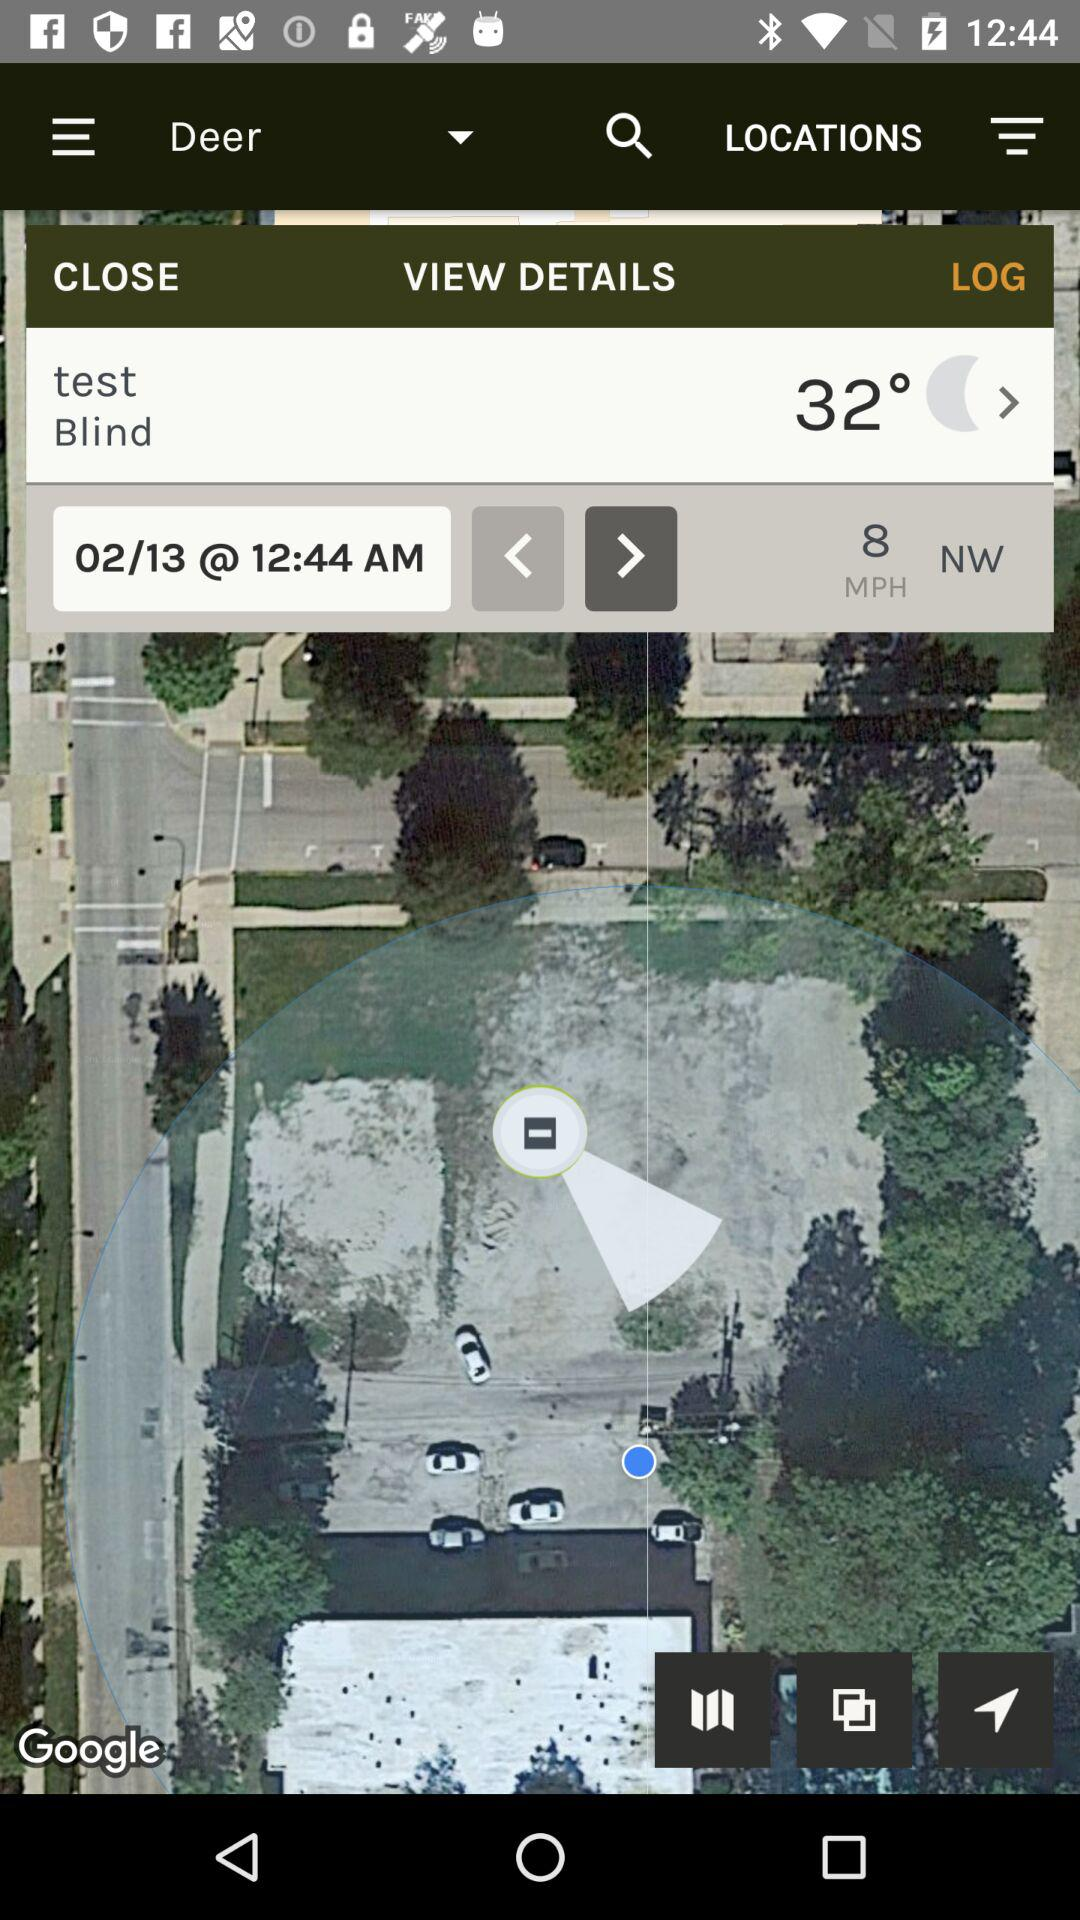What is the date and time shown on the screen? The date and time shown on the screen are February 13 and 12:44 AM respectively. 